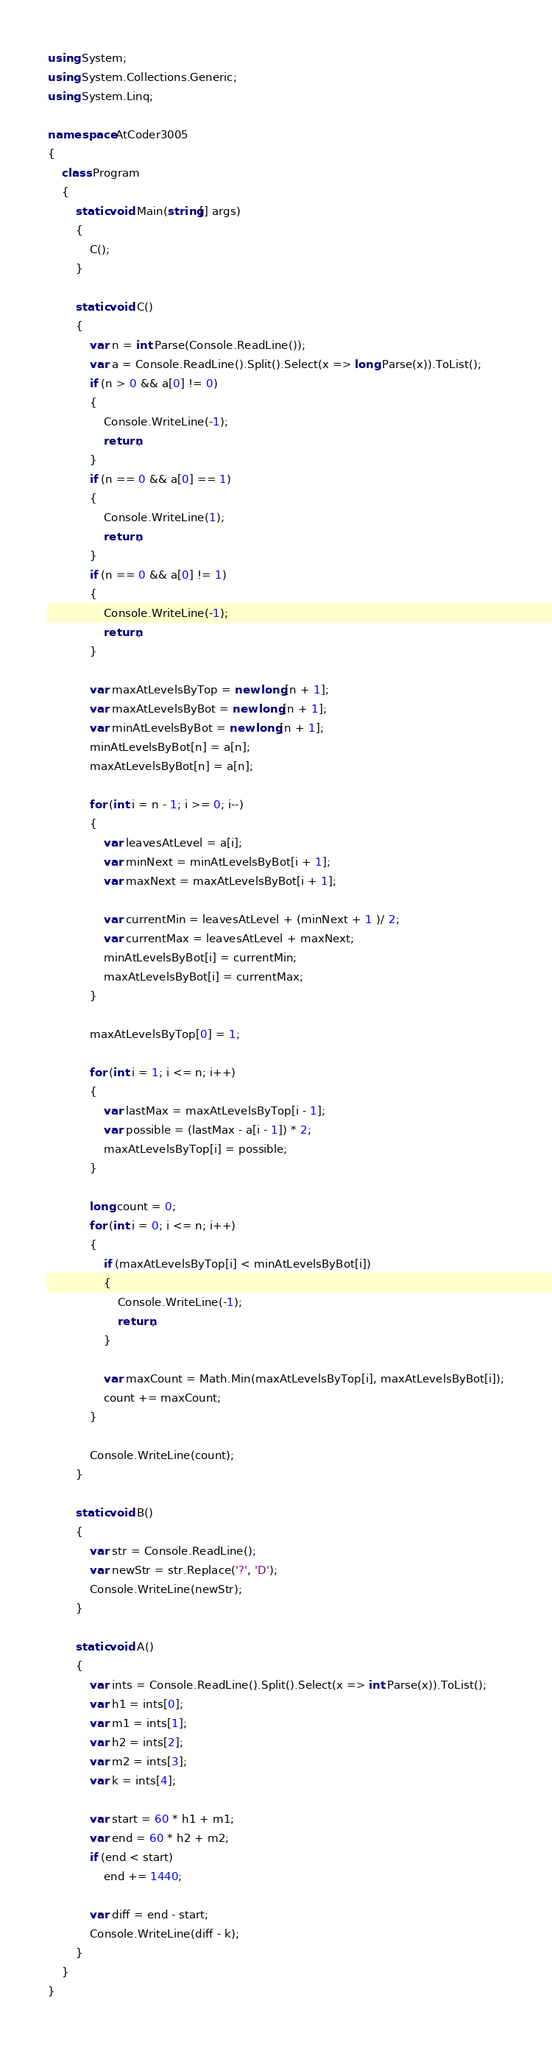Convert code to text. <code><loc_0><loc_0><loc_500><loc_500><_C#_>using System;
using System.Collections.Generic;
using System.Linq;

namespace AtCoder3005
{
	class Program
	{
		static void Main(string[] args)
		{
			C();
		}

		static void C()
		{
			var n = int.Parse(Console.ReadLine());
			var a = Console.ReadLine().Split().Select(x => long.Parse(x)).ToList();
			if (n > 0 && a[0] != 0)
			{
				Console.WriteLine(-1);
				return;
			}
			if (n == 0 && a[0] == 1)
			{
				Console.WriteLine(1);
				return;
			}
			if (n == 0 && a[0] != 1)
			{
				Console.WriteLine(-1);
				return;
			}

			var maxAtLevelsByTop = new long[n + 1];
			var maxAtLevelsByBot = new long[n + 1];
			var minAtLevelsByBot = new long[n + 1];
			minAtLevelsByBot[n] = a[n];
			maxAtLevelsByBot[n] = a[n];

			for (int i = n - 1; i >= 0; i--)
			{
				var leavesAtLevel = a[i];
				var minNext = minAtLevelsByBot[i + 1];
				var maxNext = maxAtLevelsByBot[i + 1];

				var currentMin = leavesAtLevel + (minNext + 1 )/ 2;
				var currentMax = leavesAtLevel + maxNext;
				minAtLevelsByBot[i] = currentMin;
				maxAtLevelsByBot[i] = currentMax;
			}

			maxAtLevelsByTop[0] = 1;

			for (int i = 1; i <= n; i++)
			{
				var lastMax = maxAtLevelsByTop[i - 1];
				var possible = (lastMax - a[i - 1]) * 2;
				maxAtLevelsByTop[i] = possible;
			}

			long count = 0;
			for (int i = 0; i <= n; i++)
			{
				if (maxAtLevelsByTop[i] < minAtLevelsByBot[i])
				{
					Console.WriteLine(-1);
					return;
				}

				var maxCount = Math.Min(maxAtLevelsByTop[i], maxAtLevelsByBot[i]);
				count += maxCount;
			}

			Console.WriteLine(count);
		}

		static void B()
		{
			var str = Console.ReadLine();
			var newStr = str.Replace('?', 'D');
			Console.WriteLine(newStr);
		}

		static void A()
		{
			var ints = Console.ReadLine().Split().Select(x => int.Parse(x)).ToList();
			var h1 = ints[0];
			var m1 = ints[1];
			var h2 = ints[2];
			var m2 = ints[3];
			var k = ints[4];

			var start = 60 * h1 + m1;
			var end = 60 * h2 + m2;
			if (end < start)
				end += 1440;

			var diff = end - start;
			Console.WriteLine(diff - k);
		}
	}
}
</code> 